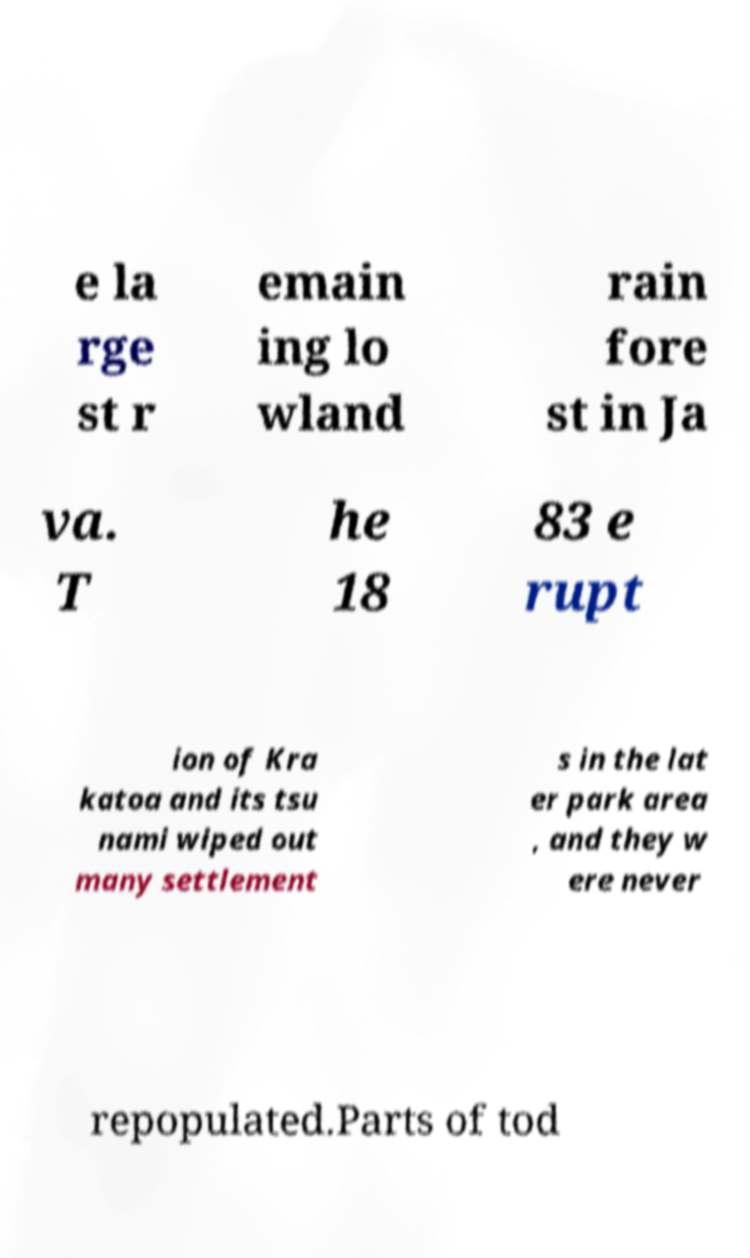Can you accurately transcribe the text from the provided image for me? e la rge st r emain ing lo wland rain fore st in Ja va. T he 18 83 e rupt ion of Kra katoa and its tsu nami wiped out many settlement s in the lat er park area , and they w ere never repopulated.Parts of tod 